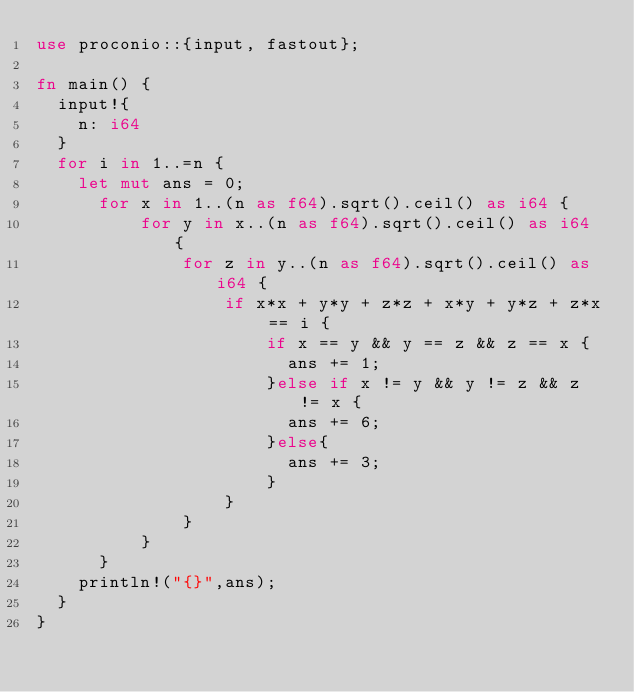Convert code to text. <code><loc_0><loc_0><loc_500><loc_500><_Rust_>use proconio::{input, fastout};

fn main() {
  input!{
    n: i64
  }
  for i in 1..=n {
    let mut ans = 0;
      for x in 1..(n as f64).sqrt().ceil() as i64 {
          for y in x..(n as f64).sqrt().ceil() as i64 {
              for z in y..(n as f64).sqrt().ceil() as i64 {
                  if x*x + y*y + z*z + x*y + y*z + z*x == i {
                      if x == y && y == z && z == x {
                        ans += 1;
                      }else if x != y && y != z && z != x {
                        ans += 6;
                      }else{
                        ans += 3;
                      }
                  }
              }
          }
      }
    println!("{}",ans);
  }  
}
</code> 